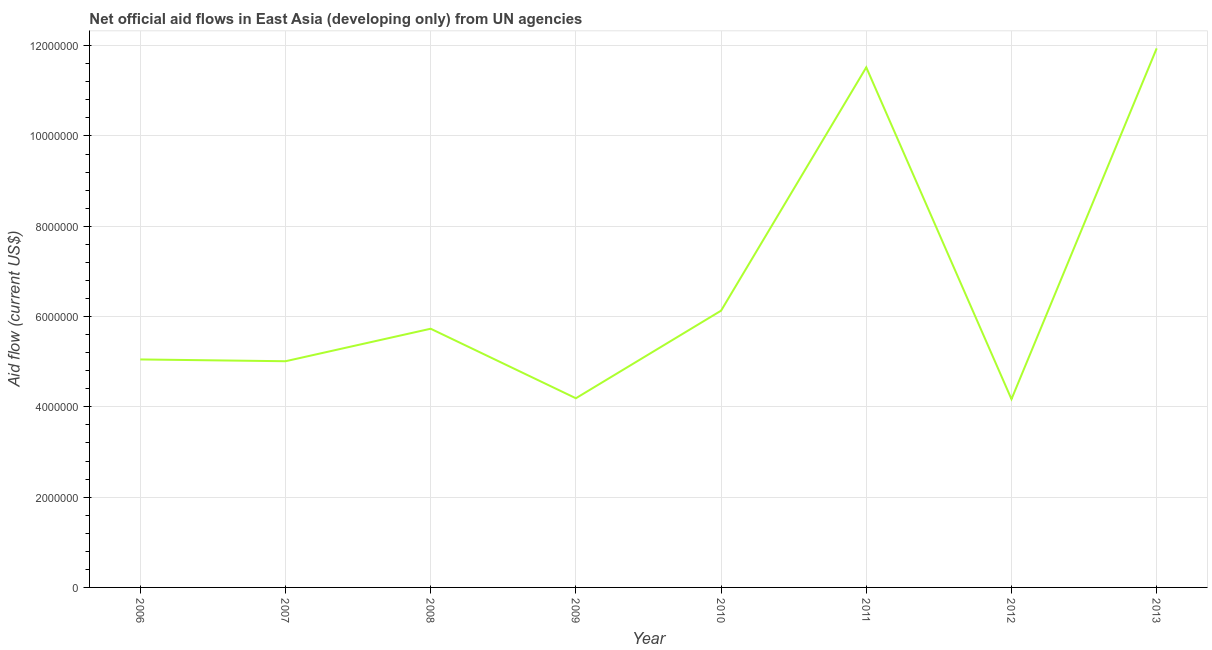What is the net official flows from un agencies in 2011?
Ensure brevity in your answer.  1.15e+07. Across all years, what is the maximum net official flows from un agencies?
Keep it short and to the point. 1.19e+07. Across all years, what is the minimum net official flows from un agencies?
Provide a short and direct response. 4.17e+06. In which year was the net official flows from un agencies maximum?
Provide a succinct answer. 2013. In which year was the net official flows from un agencies minimum?
Provide a succinct answer. 2012. What is the sum of the net official flows from un agencies?
Your response must be concise. 5.37e+07. What is the difference between the net official flows from un agencies in 2007 and 2008?
Keep it short and to the point. -7.20e+05. What is the average net official flows from un agencies per year?
Your answer should be compact. 6.72e+06. What is the median net official flows from un agencies?
Offer a terse response. 5.39e+06. What is the ratio of the net official flows from un agencies in 2008 to that in 2013?
Provide a succinct answer. 0.48. Is the net official flows from un agencies in 2008 less than that in 2011?
Ensure brevity in your answer.  Yes. Is the difference between the net official flows from un agencies in 2007 and 2012 greater than the difference between any two years?
Offer a very short reply. No. What is the difference between the highest and the second highest net official flows from un agencies?
Keep it short and to the point. 4.20e+05. Is the sum of the net official flows from un agencies in 2008 and 2011 greater than the maximum net official flows from un agencies across all years?
Offer a very short reply. Yes. What is the difference between the highest and the lowest net official flows from un agencies?
Offer a very short reply. 7.77e+06. In how many years, is the net official flows from un agencies greater than the average net official flows from un agencies taken over all years?
Your answer should be very brief. 2. How many lines are there?
Your answer should be very brief. 1. How many years are there in the graph?
Your response must be concise. 8. What is the difference between two consecutive major ticks on the Y-axis?
Your answer should be very brief. 2.00e+06. Does the graph contain grids?
Make the answer very short. Yes. What is the title of the graph?
Make the answer very short. Net official aid flows in East Asia (developing only) from UN agencies. What is the label or title of the X-axis?
Keep it short and to the point. Year. What is the Aid flow (current US$) of 2006?
Offer a terse response. 5.05e+06. What is the Aid flow (current US$) in 2007?
Give a very brief answer. 5.01e+06. What is the Aid flow (current US$) in 2008?
Your answer should be compact. 5.73e+06. What is the Aid flow (current US$) of 2009?
Your answer should be very brief. 4.19e+06. What is the Aid flow (current US$) in 2010?
Provide a succinct answer. 6.13e+06. What is the Aid flow (current US$) in 2011?
Provide a succinct answer. 1.15e+07. What is the Aid flow (current US$) of 2012?
Your answer should be compact. 4.17e+06. What is the Aid flow (current US$) in 2013?
Give a very brief answer. 1.19e+07. What is the difference between the Aid flow (current US$) in 2006 and 2007?
Keep it short and to the point. 4.00e+04. What is the difference between the Aid flow (current US$) in 2006 and 2008?
Ensure brevity in your answer.  -6.80e+05. What is the difference between the Aid flow (current US$) in 2006 and 2009?
Your answer should be very brief. 8.60e+05. What is the difference between the Aid flow (current US$) in 2006 and 2010?
Keep it short and to the point. -1.08e+06. What is the difference between the Aid flow (current US$) in 2006 and 2011?
Offer a terse response. -6.47e+06. What is the difference between the Aid flow (current US$) in 2006 and 2012?
Your answer should be compact. 8.80e+05. What is the difference between the Aid flow (current US$) in 2006 and 2013?
Keep it short and to the point. -6.89e+06. What is the difference between the Aid flow (current US$) in 2007 and 2008?
Provide a short and direct response. -7.20e+05. What is the difference between the Aid flow (current US$) in 2007 and 2009?
Make the answer very short. 8.20e+05. What is the difference between the Aid flow (current US$) in 2007 and 2010?
Provide a succinct answer. -1.12e+06. What is the difference between the Aid flow (current US$) in 2007 and 2011?
Provide a short and direct response. -6.51e+06. What is the difference between the Aid flow (current US$) in 2007 and 2012?
Make the answer very short. 8.40e+05. What is the difference between the Aid flow (current US$) in 2007 and 2013?
Ensure brevity in your answer.  -6.93e+06. What is the difference between the Aid flow (current US$) in 2008 and 2009?
Give a very brief answer. 1.54e+06. What is the difference between the Aid flow (current US$) in 2008 and 2010?
Your response must be concise. -4.00e+05. What is the difference between the Aid flow (current US$) in 2008 and 2011?
Make the answer very short. -5.79e+06. What is the difference between the Aid flow (current US$) in 2008 and 2012?
Keep it short and to the point. 1.56e+06. What is the difference between the Aid flow (current US$) in 2008 and 2013?
Your response must be concise. -6.21e+06. What is the difference between the Aid flow (current US$) in 2009 and 2010?
Offer a terse response. -1.94e+06. What is the difference between the Aid flow (current US$) in 2009 and 2011?
Give a very brief answer. -7.33e+06. What is the difference between the Aid flow (current US$) in 2009 and 2012?
Ensure brevity in your answer.  2.00e+04. What is the difference between the Aid flow (current US$) in 2009 and 2013?
Ensure brevity in your answer.  -7.75e+06. What is the difference between the Aid flow (current US$) in 2010 and 2011?
Give a very brief answer. -5.39e+06. What is the difference between the Aid flow (current US$) in 2010 and 2012?
Your answer should be very brief. 1.96e+06. What is the difference between the Aid flow (current US$) in 2010 and 2013?
Your answer should be compact. -5.81e+06. What is the difference between the Aid flow (current US$) in 2011 and 2012?
Provide a short and direct response. 7.35e+06. What is the difference between the Aid flow (current US$) in 2011 and 2013?
Give a very brief answer. -4.20e+05. What is the difference between the Aid flow (current US$) in 2012 and 2013?
Your answer should be compact. -7.77e+06. What is the ratio of the Aid flow (current US$) in 2006 to that in 2007?
Offer a terse response. 1.01. What is the ratio of the Aid flow (current US$) in 2006 to that in 2008?
Ensure brevity in your answer.  0.88. What is the ratio of the Aid flow (current US$) in 2006 to that in 2009?
Keep it short and to the point. 1.21. What is the ratio of the Aid flow (current US$) in 2006 to that in 2010?
Provide a succinct answer. 0.82. What is the ratio of the Aid flow (current US$) in 2006 to that in 2011?
Offer a very short reply. 0.44. What is the ratio of the Aid flow (current US$) in 2006 to that in 2012?
Provide a succinct answer. 1.21. What is the ratio of the Aid flow (current US$) in 2006 to that in 2013?
Offer a very short reply. 0.42. What is the ratio of the Aid flow (current US$) in 2007 to that in 2008?
Give a very brief answer. 0.87. What is the ratio of the Aid flow (current US$) in 2007 to that in 2009?
Your response must be concise. 1.2. What is the ratio of the Aid flow (current US$) in 2007 to that in 2010?
Keep it short and to the point. 0.82. What is the ratio of the Aid flow (current US$) in 2007 to that in 2011?
Provide a short and direct response. 0.43. What is the ratio of the Aid flow (current US$) in 2007 to that in 2012?
Your answer should be compact. 1.2. What is the ratio of the Aid flow (current US$) in 2007 to that in 2013?
Provide a succinct answer. 0.42. What is the ratio of the Aid flow (current US$) in 2008 to that in 2009?
Ensure brevity in your answer.  1.37. What is the ratio of the Aid flow (current US$) in 2008 to that in 2010?
Keep it short and to the point. 0.94. What is the ratio of the Aid flow (current US$) in 2008 to that in 2011?
Keep it short and to the point. 0.5. What is the ratio of the Aid flow (current US$) in 2008 to that in 2012?
Keep it short and to the point. 1.37. What is the ratio of the Aid flow (current US$) in 2008 to that in 2013?
Your answer should be very brief. 0.48. What is the ratio of the Aid flow (current US$) in 2009 to that in 2010?
Ensure brevity in your answer.  0.68. What is the ratio of the Aid flow (current US$) in 2009 to that in 2011?
Your response must be concise. 0.36. What is the ratio of the Aid flow (current US$) in 2009 to that in 2012?
Give a very brief answer. 1. What is the ratio of the Aid flow (current US$) in 2009 to that in 2013?
Offer a terse response. 0.35. What is the ratio of the Aid flow (current US$) in 2010 to that in 2011?
Offer a terse response. 0.53. What is the ratio of the Aid flow (current US$) in 2010 to that in 2012?
Provide a succinct answer. 1.47. What is the ratio of the Aid flow (current US$) in 2010 to that in 2013?
Keep it short and to the point. 0.51. What is the ratio of the Aid flow (current US$) in 2011 to that in 2012?
Provide a short and direct response. 2.76. What is the ratio of the Aid flow (current US$) in 2011 to that in 2013?
Keep it short and to the point. 0.96. What is the ratio of the Aid flow (current US$) in 2012 to that in 2013?
Your answer should be very brief. 0.35. 